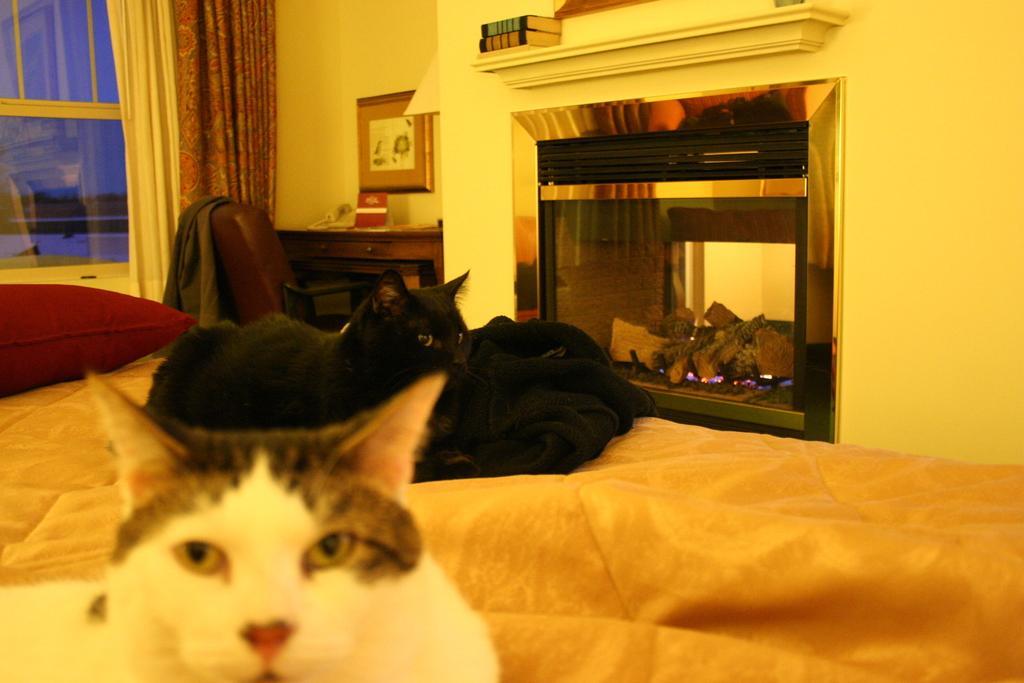Can you describe this image briefly? In this picture there are two cats sitting on the bed. There is a pillow. There is a desk curtain , books and other objects. There is a chair and a jacket. 